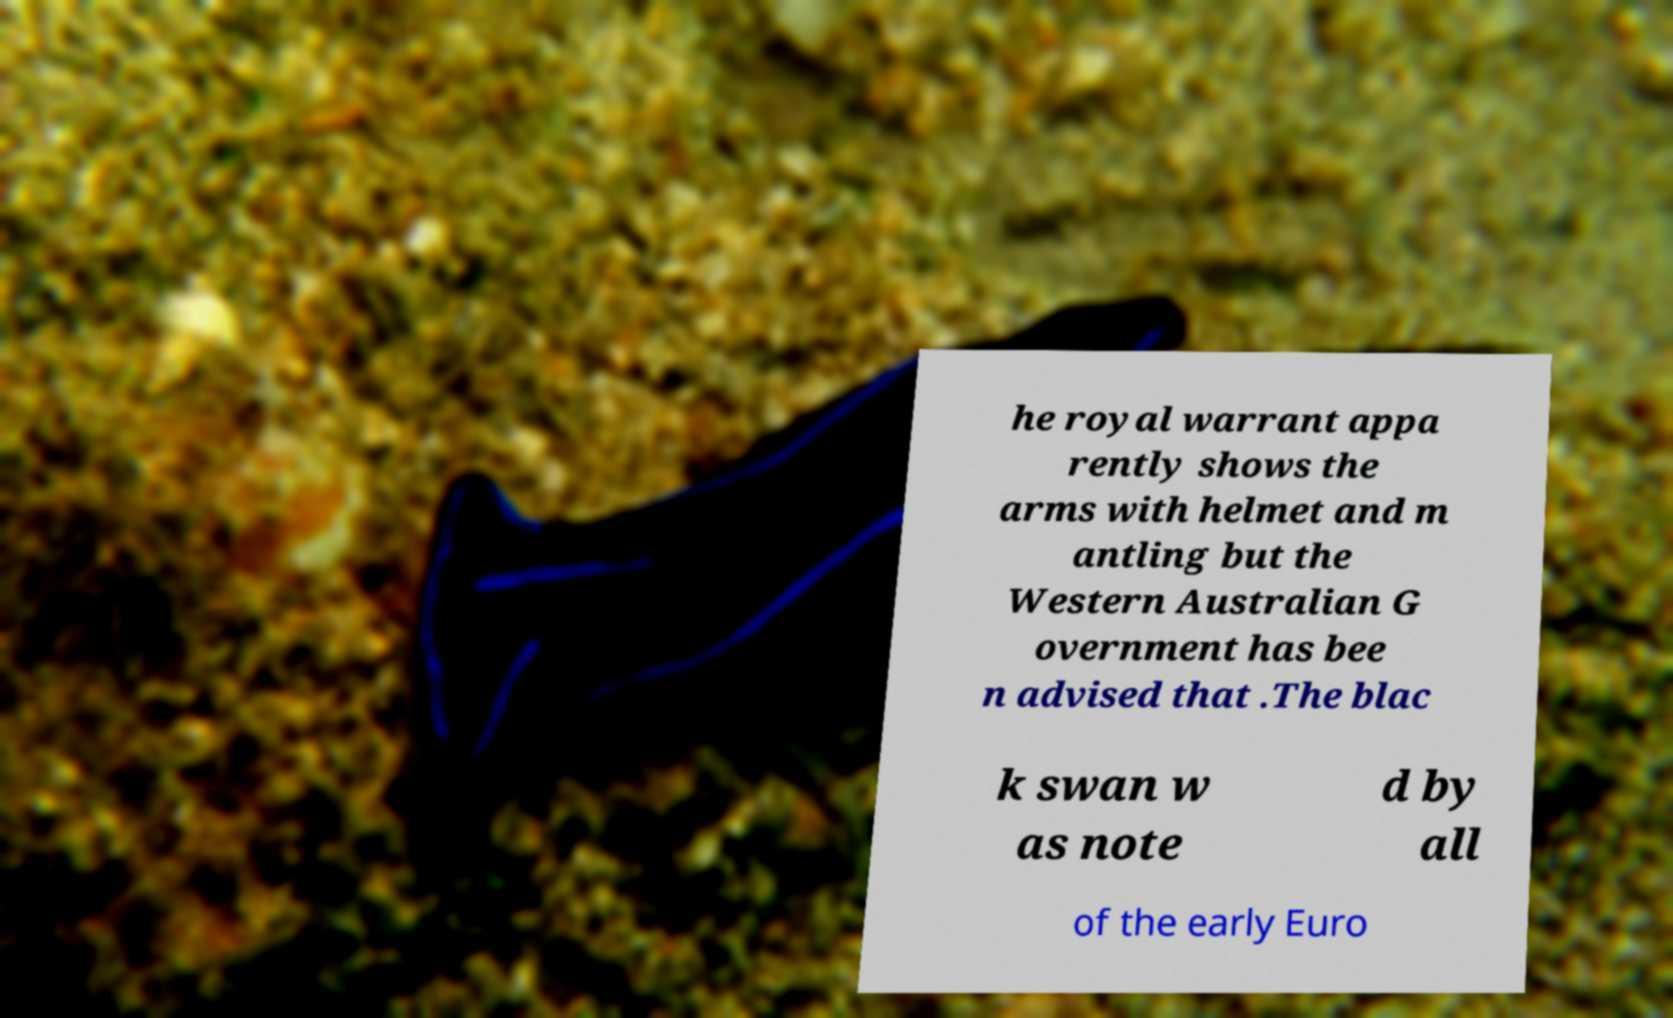Can you read and provide the text displayed in the image?This photo seems to have some interesting text. Can you extract and type it out for me? he royal warrant appa rently shows the arms with helmet and m antling but the Western Australian G overnment has bee n advised that .The blac k swan w as note d by all of the early Euro 